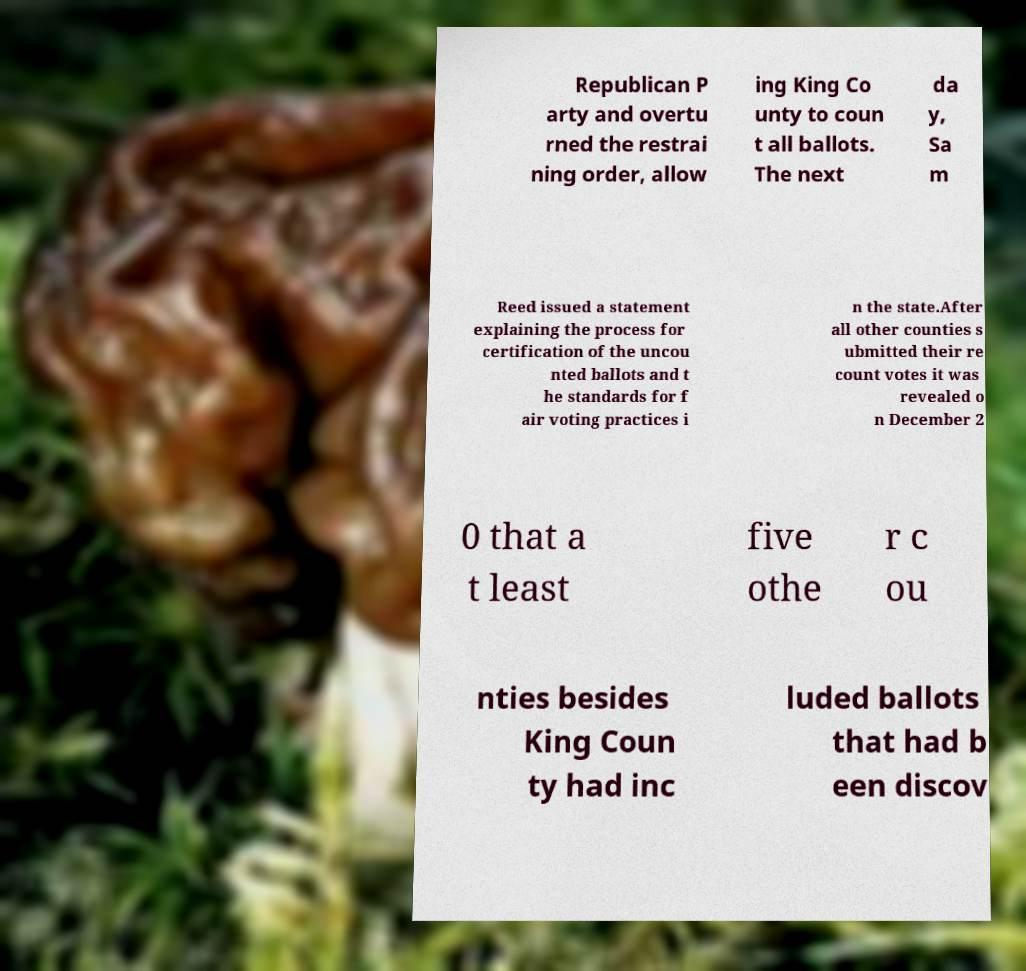I need the written content from this picture converted into text. Can you do that? Republican P arty and overtu rned the restrai ning order, allow ing King Co unty to coun t all ballots. The next da y, Sa m Reed issued a statement explaining the process for certification of the uncou nted ballots and t he standards for f air voting practices i n the state.After all other counties s ubmitted their re count votes it was revealed o n December 2 0 that a t least five othe r c ou nties besides King Coun ty had inc luded ballots that had b een discov 